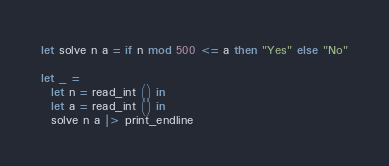Convert code to text. <code><loc_0><loc_0><loc_500><loc_500><_OCaml_>let solve n a = if n mod 500 <= a then "Yes" else "No"

let _ =
  let n = read_int () in
  let a = read_int () in
  solve n a |> print_endline</code> 